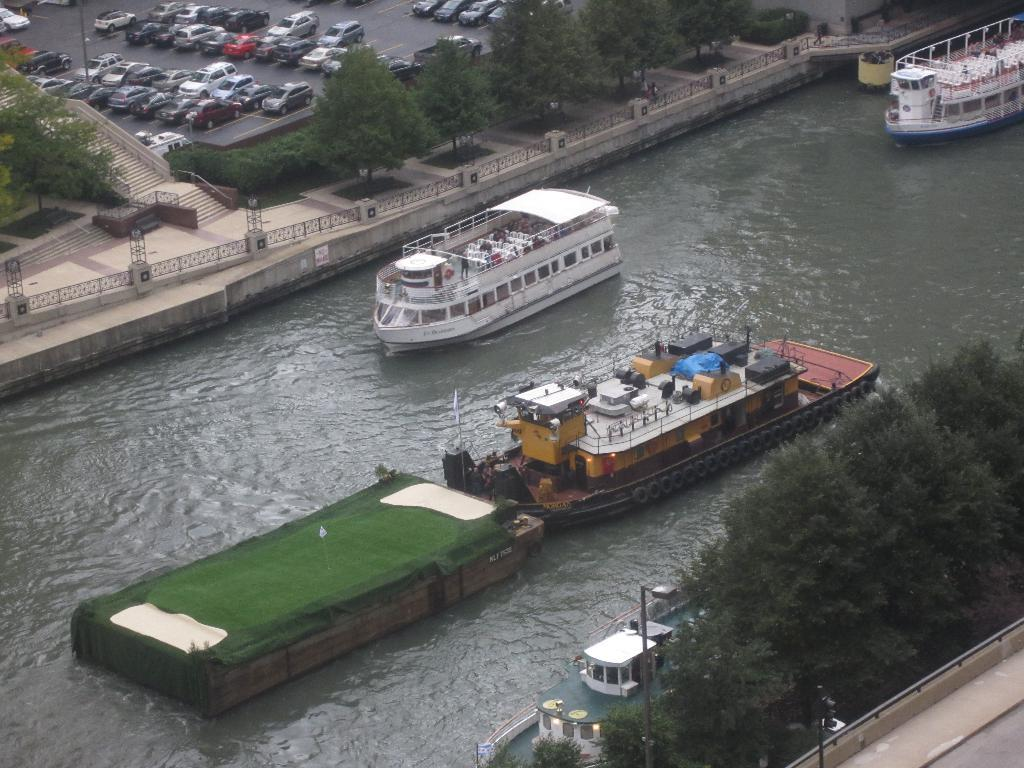What is in the water in the image? There are boats in the water. What can be seen in the background of the image? There are trees and vehicles visible in the background. How many dogs are sitting on the boats in the image? There are no dogs present in the image; it features boats in the water. Can you see a cobweb hanging from any of the trees in the background? There is no mention of a cobweb in the image, and it is not possible to determine its presence based on the provided facts. 